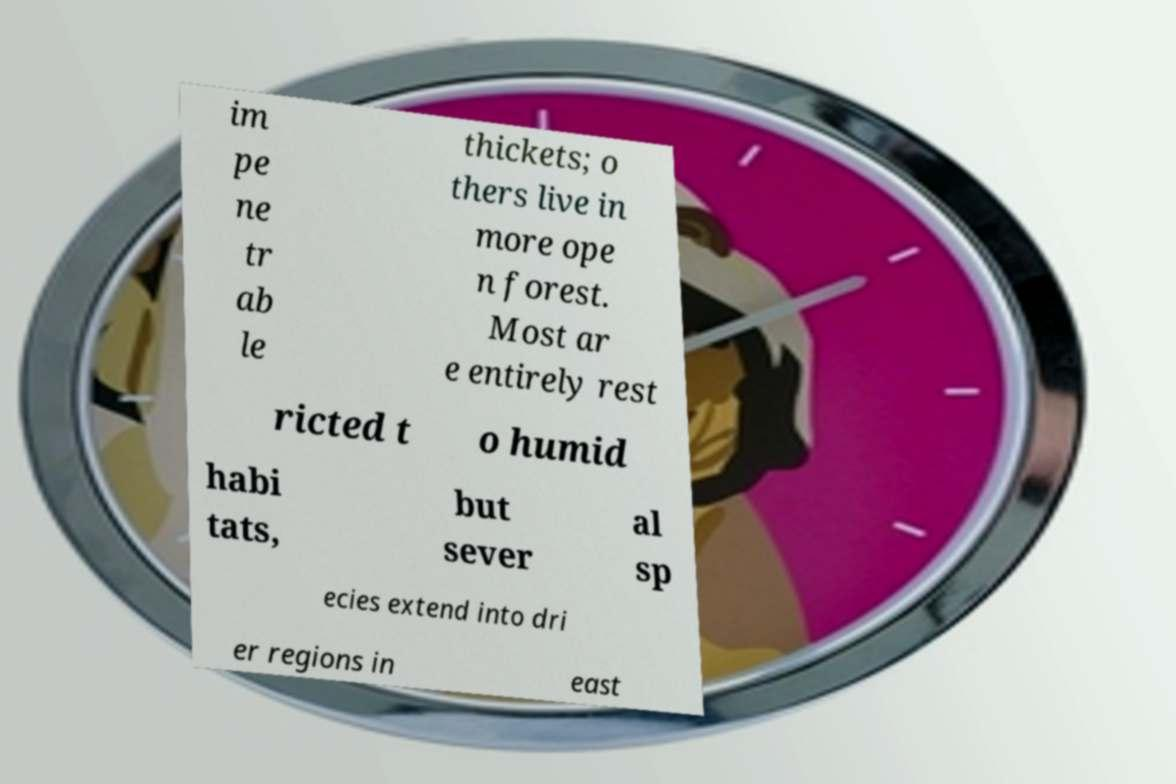Could you extract and type out the text from this image? im pe ne tr ab le thickets; o thers live in more ope n forest. Most ar e entirely rest ricted t o humid habi tats, but sever al sp ecies extend into dri er regions in east 